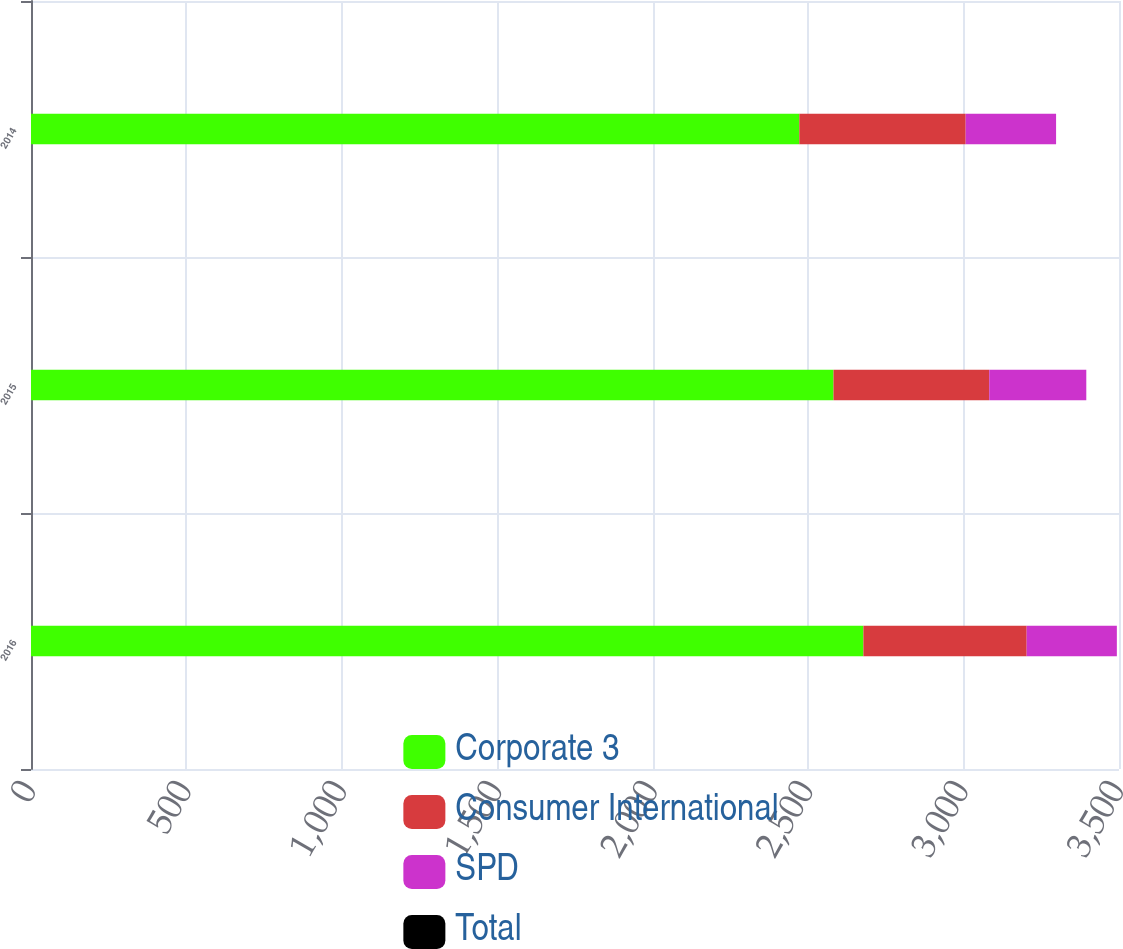<chart> <loc_0><loc_0><loc_500><loc_500><stacked_bar_chart><ecel><fcel>2016<fcel>2015<fcel>2014<nl><fcel>Corporate 3<fcel>2677.8<fcel>2581.6<fcel>2471.6<nl><fcel>Consumer International<fcel>525.2<fcel>501<fcel>535.2<nl><fcel>SPD<fcel>290.1<fcel>312.2<fcel>290.8<nl><fcel>Total<fcel>0<fcel>0<fcel>0<nl></chart> 